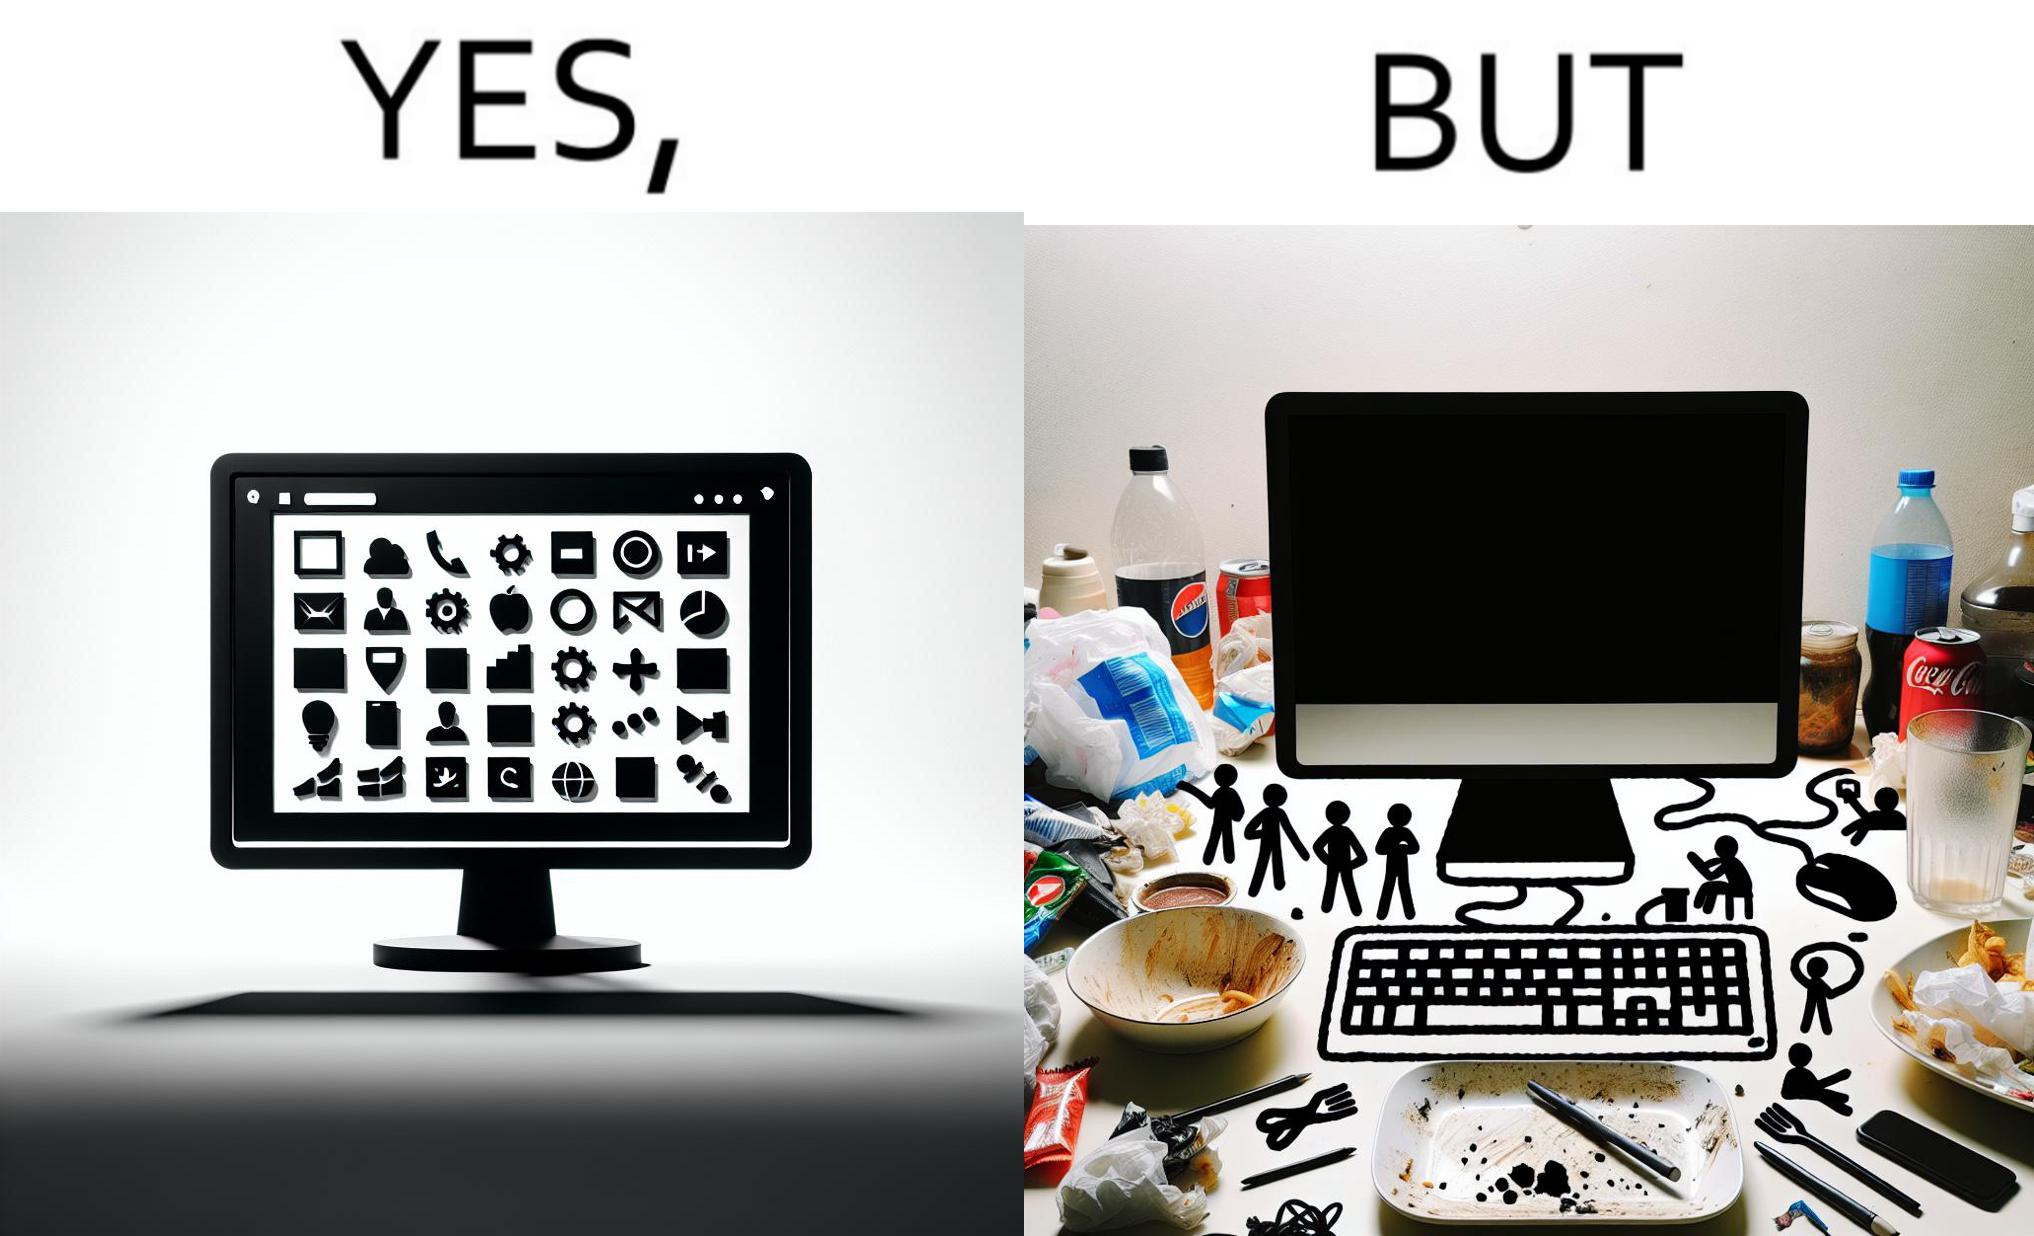Is this image satirical or non-satirical? Yes, this image is satirical. 